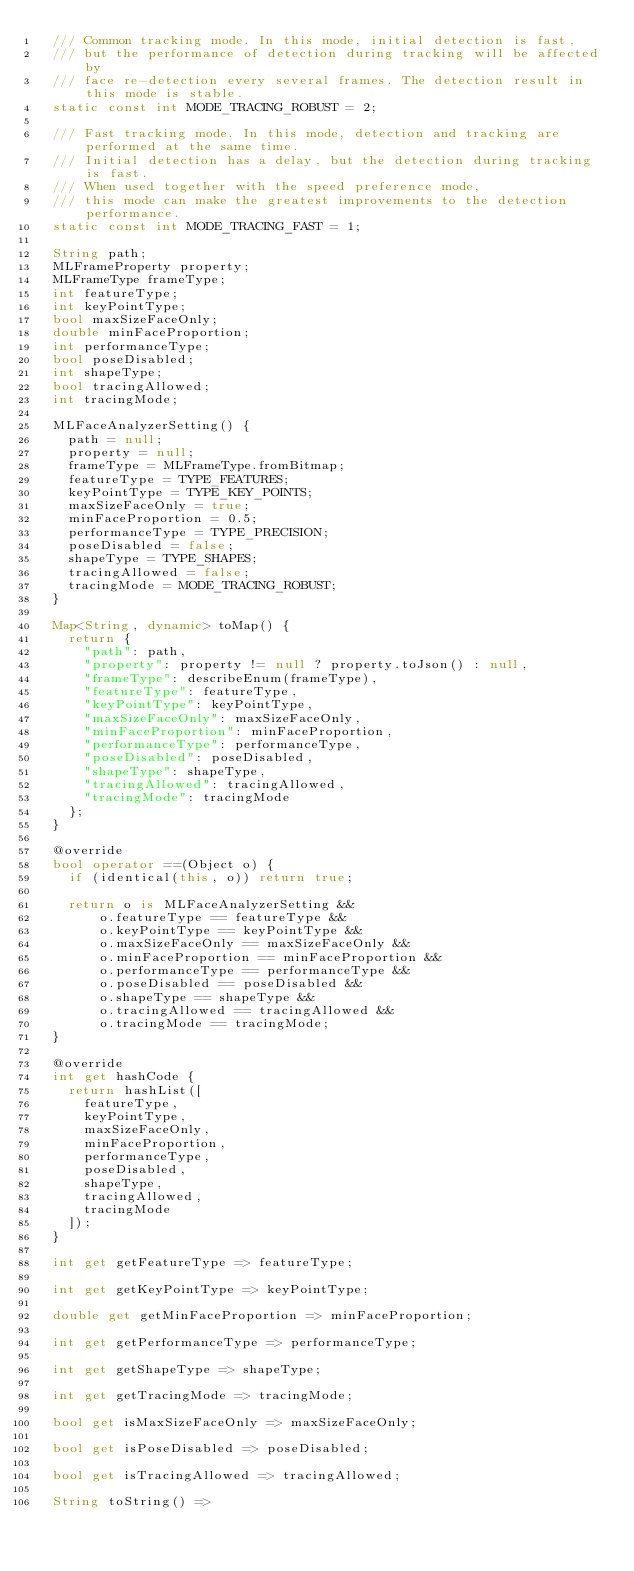<code> <loc_0><loc_0><loc_500><loc_500><_Dart_>  /// Common tracking mode. In this mode, initial detection is fast,
  /// but the performance of detection during tracking will be affected by
  /// face re-detection every several frames. The detection result in this mode is stable.
  static const int MODE_TRACING_ROBUST = 2;

  /// Fast tracking mode. In this mode, detection and tracking are performed at the same time.
  /// Initial detection has a delay, but the detection during tracking is fast.
  /// When used together with the speed preference mode,
  /// this mode can make the greatest improvements to the detection performance.
  static const int MODE_TRACING_FAST = 1;

  String path;
  MLFrameProperty property;
  MLFrameType frameType;
  int featureType;
  int keyPointType;
  bool maxSizeFaceOnly;
  double minFaceProportion;
  int performanceType;
  bool poseDisabled;
  int shapeType;
  bool tracingAllowed;
  int tracingMode;

  MLFaceAnalyzerSetting() {
    path = null;
    property = null;
    frameType = MLFrameType.fromBitmap;
    featureType = TYPE_FEATURES;
    keyPointType = TYPE_KEY_POINTS;
    maxSizeFaceOnly = true;
    minFaceProportion = 0.5;
    performanceType = TYPE_PRECISION;
    poseDisabled = false;
    shapeType = TYPE_SHAPES;
    tracingAllowed = false;
    tracingMode = MODE_TRACING_ROBUST;
  }

  Map<String, dynamic> toMap() {
    return {
      "path": path,
      "property": property != null ? property.toJson() : null,
      "frameType": describeEnum(frameType),
      "featureType": featureType,
      "keyPointType": keyPointType,
      "maxSizeFaceOnly": maxSizeFaceOnly,
      "minFaceProportion": minFaceProportion,
      "performanceType": performanceType,
      "poseDisabled": poseDisabled,
      "shapeType": shapeType,
      "tracingAllowed": tracingAllowed,
      "tracingMode": tracingMode
    };
  }

  @override
  bool operator ==(Object o) {
    if (identical(this, o)) return true;

    return o is MLFaceAnalyzerSetting &&
        o.featureType == featureType &&
        o.keyPointType == keyPointType &&
        o.maxSizeFaceOnly == maxSizeFaceOnly &&
        o.minFaceProportion == minFaceProportion &&
        o.performanceType == performanceType &&
        o.poseDisabled == poseDisabled &&
        o.shapeType == shapeType &&
        o.tracingAllowed == tracingAllowed &&
        o.tracingMode == tracingMode;
  }

  @override
  int get hashCode {
    return hashList([
      featureType,
      keyPointType,
      maxSizeFaceOnly,
      minFaceProportion,
      performanceType,
      poseDisabled,
      shapeType,
      tracingAllowed,
      tracingMode
    ]);
  }

  int get getFeatureType => featureType;

  int get getKeyPointType => keyPointType;

  double get getMinFaceProportion => minFaceProportion;

  int get getPerformanceType => performanceType;

  int get getShapeType => shapeType;

  int get getTracingMode => tracingMode;

  bool get isMaxSizeFaceOnly => maxSizeFaceOnly;

  bool get isPoseDisabled => poseDisabled;

  bool get isTracingAllowed => tracingAllowed;

  String toString() =></code> 